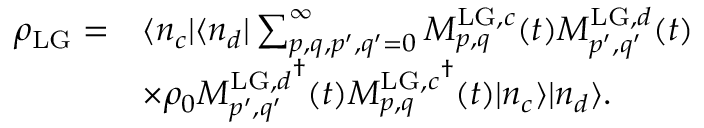<formula> <loc_0><loc_0><loc_500><loc_500>\begin{array} { r l } { \rho _ { L G } = } & { \langle n _ { c } | \langle n _ { d } | \sum _ { p , q , p ^ { \prime } , q ^ { \prime } = 0 } ^ { \infty } M _ { p , q } ^ { L G , c } ( t ) M _ { p ^ { \prime } , q ^ { \prime } } ^ { L G , d } ( t ) } \\ & { \times \rho _ { 0 } { M _ { p ^ { \prime } , q ^ { \prime } } ^ { L G , d } } ^ { \dagger } ( t ) { M _ { p , q } ^ { L G , c } } ^ { \dagger } ( t ) | n _ { c } \rangle | n _ { d } \rangle . } \end{array}</formula> 